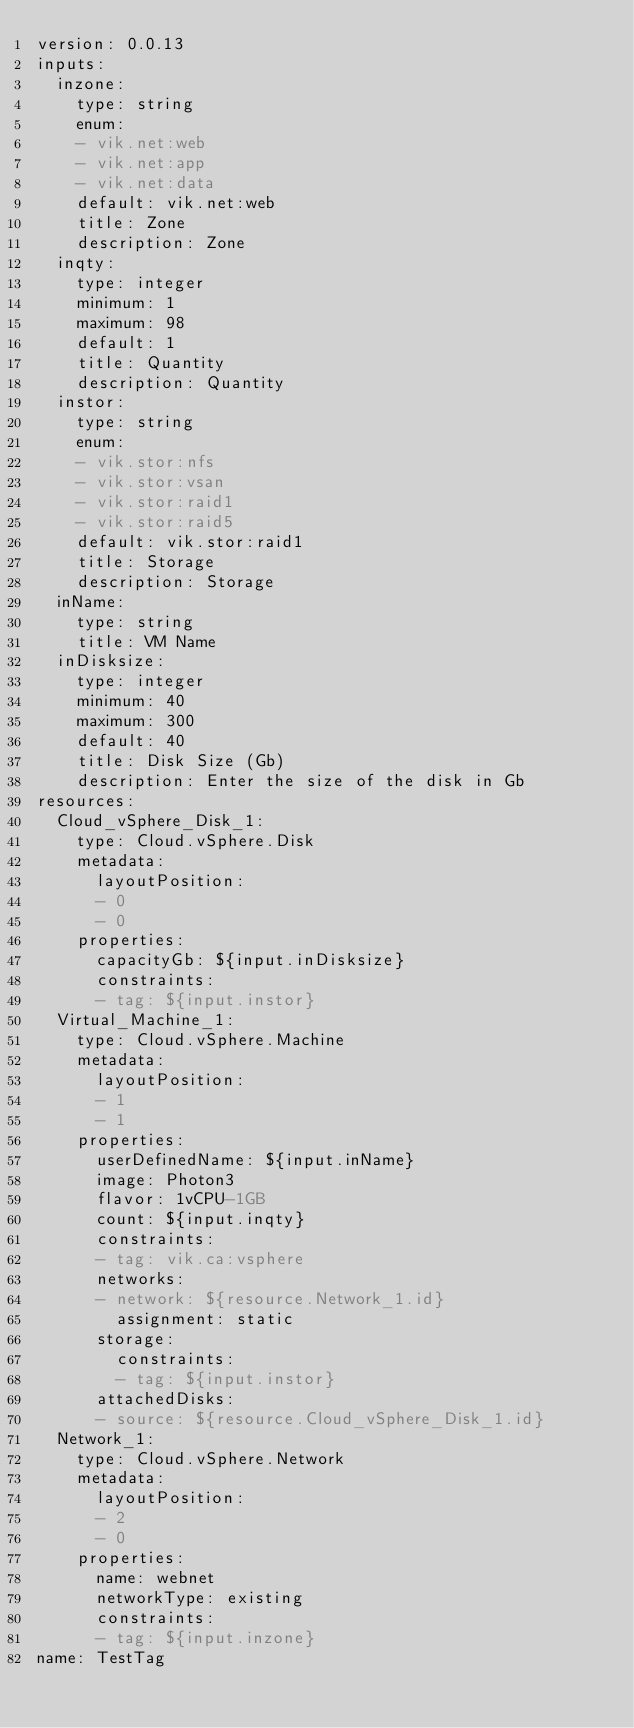<code> <loc_0><loc_0><loc_500><loc_500><_YAML_>version: 0.0.13
inputs:
  inzone:
    type: string
    enum:
    - vik.net:web
    - vik.net:app
    - vik.net:data
    default: vik.net:web
    title: Zone
    description: Zone
  inqty:
    type: integer
    minimum: 1
    maximum: 98
    default: 1
    title: Quantity
    description: Quantity
  instor:
    type: string
    enum:
    - vik.stor:nfs
    - vik.stor:vsan
    - vik.stor:raid1
    - vik.stor:raid5
    default: vik.stor:raid1
    title: Storage
    description: Storage
  inName:
    type: string
    title: VM Name
  inDisksize:
    type: integer
    minimum: 40
    maximum: 300
    default: 40
    title: Disk Size (Gb)
    description: Enter the size of the disk in Gb
resources:
  Cloud_vSphere_Disk_1:
    type: Cloud.vSphere.Disk
    metadata:
      layoutPosition:
      - 0
      - 0
    properties:
      capacityGb: ${input.inDisksize}
      constraints:
      - tag: ${input.instor}
  Virtual_Machine_1:
    type: Cloud.vSphere.Machine
    metadata:
      layoutPosition:
      - 1
      - 1
    properties:
      userDefinedName: ${input.inName}
      image: Photon3
      flavor: 1vCPU-1GB
      count: ${input.inqty}
      constraints:
      - tag: vik.ca:vsphere
      networks:
      - network: ${resource.Network_1.id}
        assignment: static
      storage:
        constraints:
        - tag: ${input.instor}
      attachedDisks:
      - source: ${resource.Cloud_vSphere_Disk_1.id}
  Network_1:
    type: Cloud.vSphere.Network
    metadata:
      layoutPosition:
      - 2
      - 0
    properties:
      name: webnet
      networkType: existing
      constraints:
      - tag: ${input.inzone}
name: TestTag
</code> 